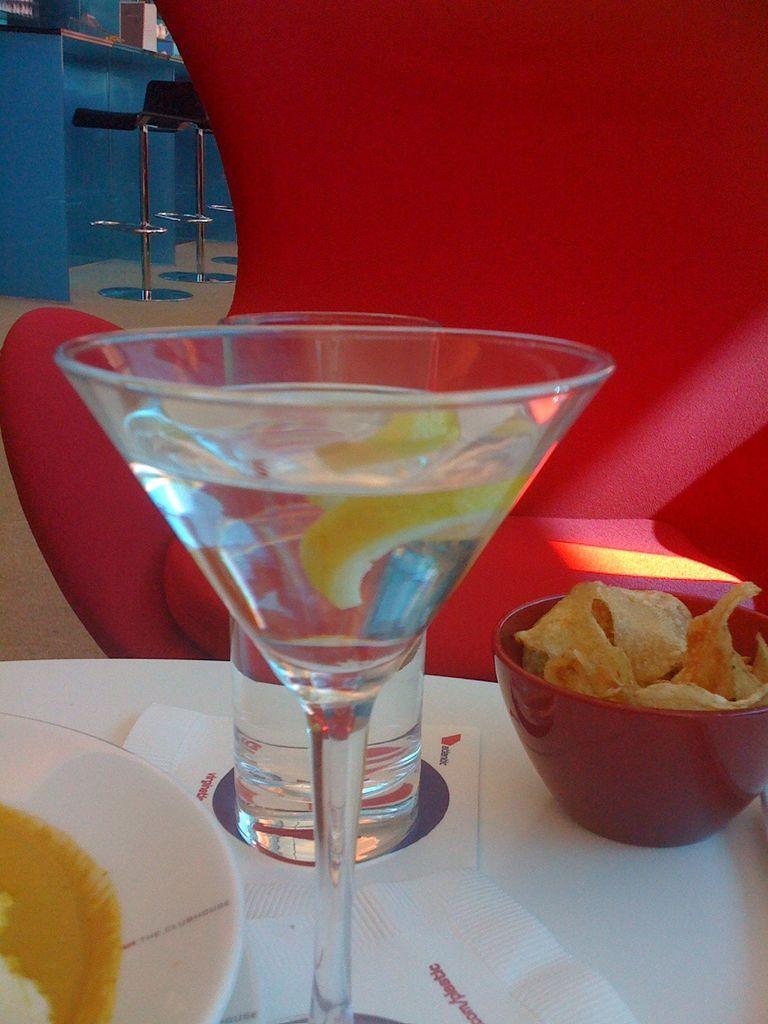Can you describe this image briefly? In the image,there is some drink in a glass and beside the glass there are chips kept in a bowl and all these are kept on the table and served and in front of the table there is a red chair. 